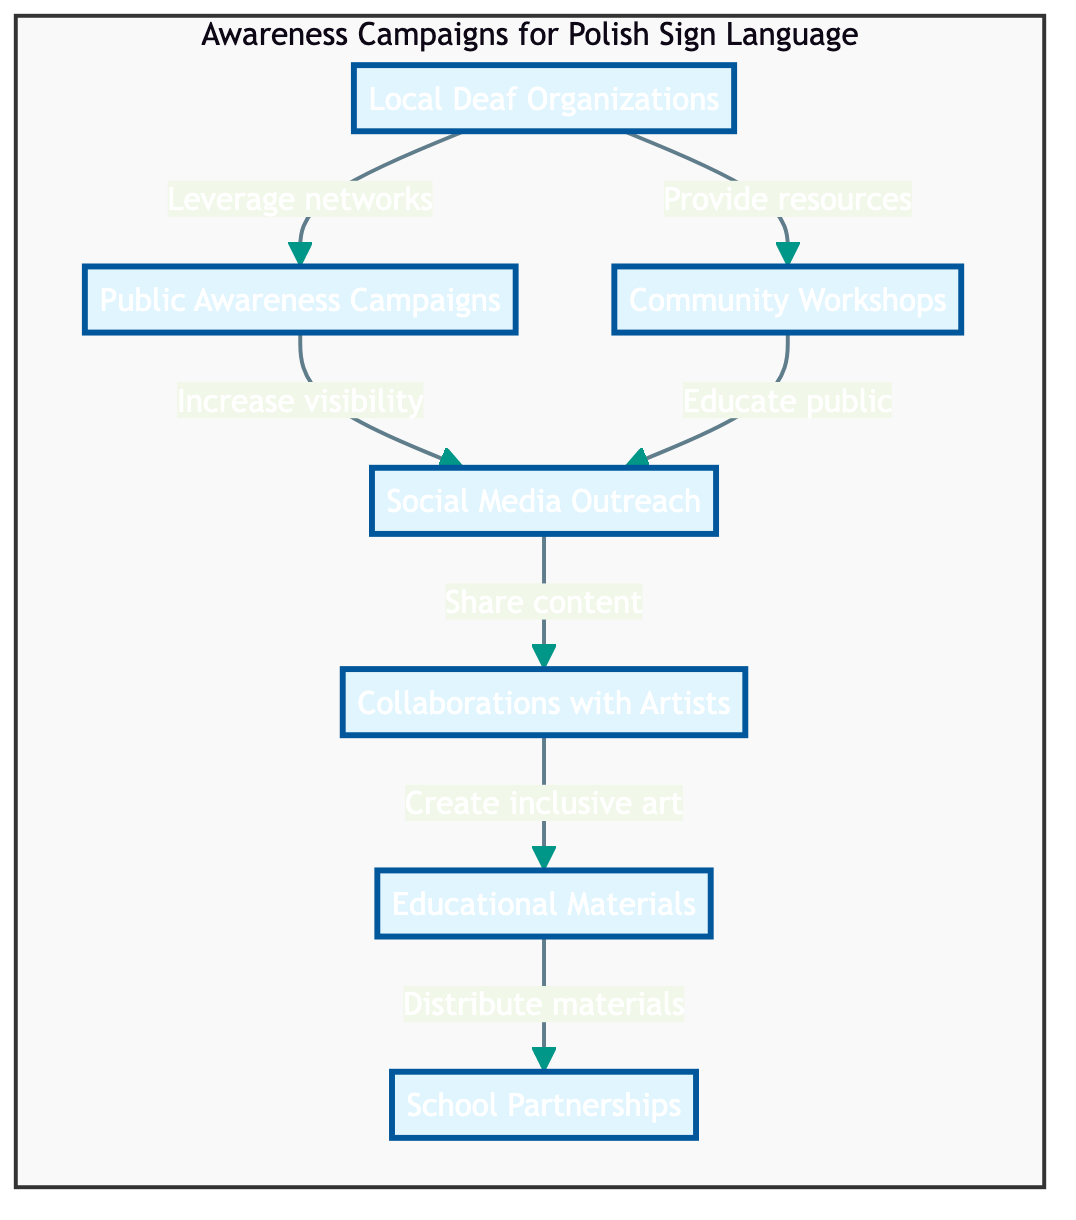What is the first node in the diagram? The first node named in the awareness campaign is "Local Deaf Organizations," which is at the top of the flow chart.
Answer: Local Deaf Organizations How many nodes are in the diagram? Counting all the distinct elements listed in the diagram, there are seven nodes related to the awareness campaign for Polish Sign Language.
Answer: 7 What action does "Local Deaf Organizations" support? The arrow from "Local Deaf Organizations" points to "Public Awareness Campaigns," indicating that their role is to leverage networks, helping to support this campaign.
Answer: Leverage networks Which two nodes are connected by the action "Educate public"? The action "Educate public" connects "Community Workshops" to "Social Media Outreach," indicating a flow of information and support between these two elements in raising awareness.
Answer: Community Workshops and Social Media Outreach What type of organizations are involved in the partnership? The node describes "School Partnerships," indicating that collaborations with schools are included to integrate sign language education within their curriculum.
Answer: Schools Which node has a direct link to the "Educational Materials"? The "Collaborations with Artists" node shows a direct link to "Educational Materials," suggesting that artists contribute to creating and distributing educational resources about sign language.
Answer: Collaborations with Artists What is the main goal of the "Public Awareness Campaigns"? The primary aim stated for "Public Awareness Campaigns" in the diagram is to increase visibility of Polish Sign Language among the public, thereby fostering greater awareness and understanding.
Answer: Increase visibility How do "Social Media Outreach" and "Collaborations with Artists" interact in the diagram? These two nodes are connected in the diagram through "Share content," indicating that both actions contribute to showcasing sign language awareness across various media platforms.
Answer: Share content What is the last node to connect back to the main campaign? The last action from "School Partnerships" links back to the awareness campaign, illustrating how integrating sign language into curricula completes the cycle of promoting awareness in educational environments.
Answer: School Partnerships 